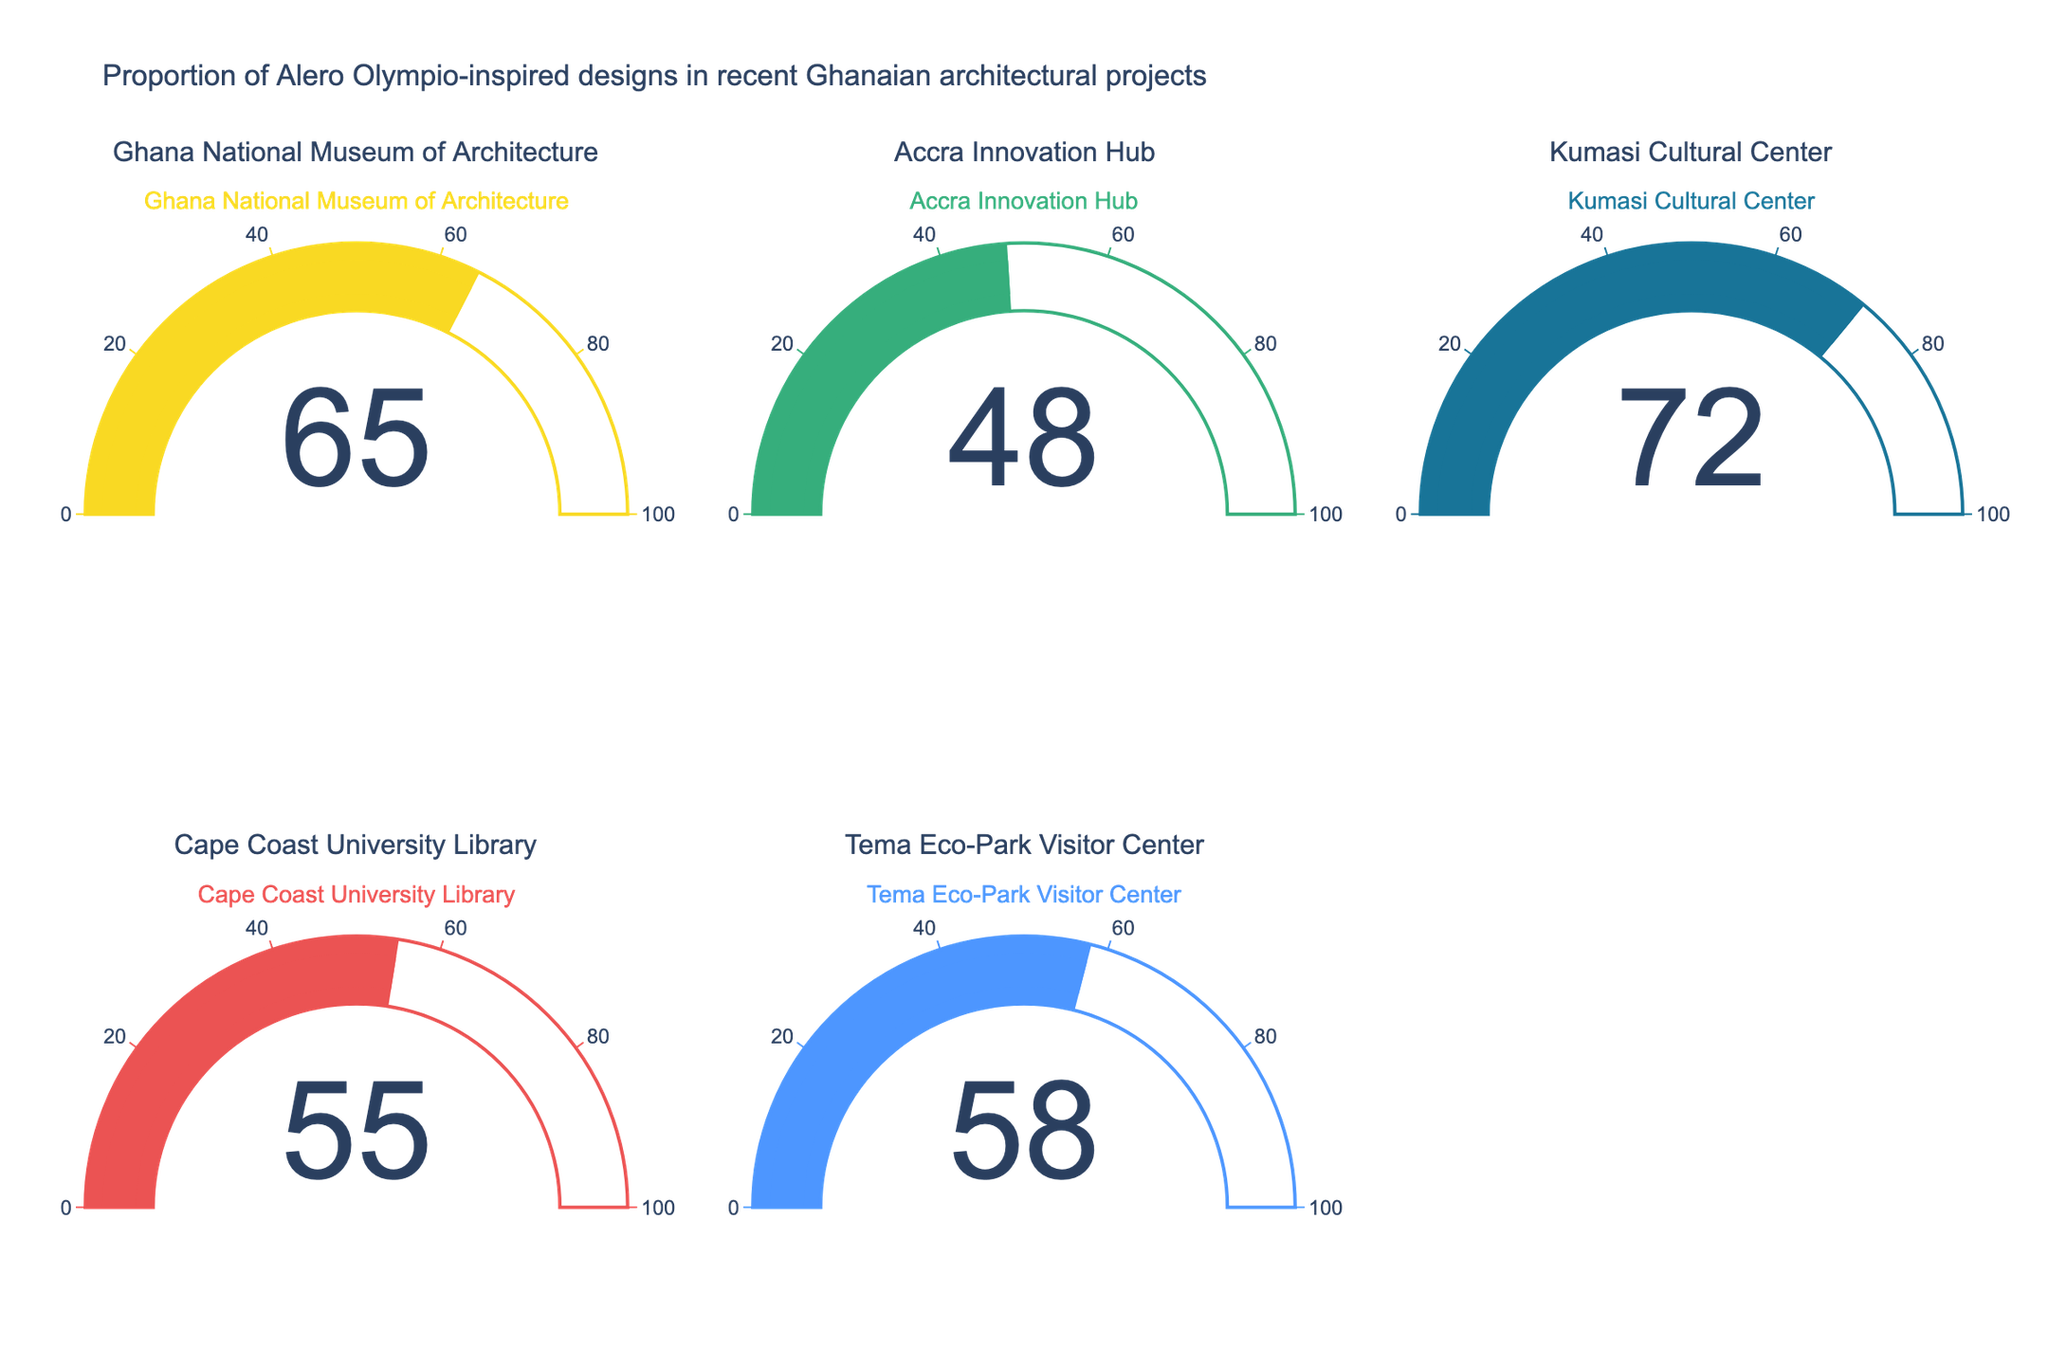What is the title of the figure? The title is usually placed at the top and summarizes the purpose or content of the figure. In this case, it identifies what proportion of designs are inspired by Alero Olympio in recent Ghanaian architectural projects.
Answer: Proportion of Alero Olympio-inspired designs in recent Ghanaian architectural projects What project has the highest proportion of Alero Olympio-inspired designs? By looking at the gauges, we can see the percentage values for each project. The project with the highest percentage is the one with the largest number displayed.
Answer: Kumasi Cultural Center What is the percentage for the Cape Coast University Library? Each gauge displays a number that indicates the percentage for the corresponding project. Find the gauge with the Cape Coast University Library label to get the percentage.
Answer: 55 Which projects have a percentage above 60? We need to identify the gauges with percentage values displayed above 60 and list their corresponding projects.
Answer: Ghana National Museum of Architecture, Kumasi Cultural Center What is the median percentage of Alero Olympio-inspired designs across all projects? To find the median, we first list the percentages in ascending order (48, 55, 58, 65, 72). The median is the middle value in this ordered list.
Answer: 58 How much higher is the percentage for Kumasi Cultural Center compared to Accra Innovation Hub? Subtract the percentage for Accra Innovation Hub from the percentage for Kumasi Cultural Center.
Answer: 72 - 48 = 24 Which project has the lowest proportion of Alero Olympio-inspired designs? By looking at the gauges, we can see the percentage values for each project. The project with the lowest percentage is the one with the smallest number displayed.
Answer: Accra Innovation Hub What is the average proportion of Alero Olympio-inspired designs across all projects? Sum all the percentages (65 + 48 + 72 + 55 + 58) and divide by the number of projects (5).
Answer: (65 + 48 + 72 + 55 + 58) / 5 = 59.6 Is the proportion of Alero Olympio-inspired designs higher in Tema Eco-Park Visitor Center or Ghana National Museum of Architecture? Compare the percentages displayed in the gauges for these two projects.
Answer: Ghana National Museum of Architecture 